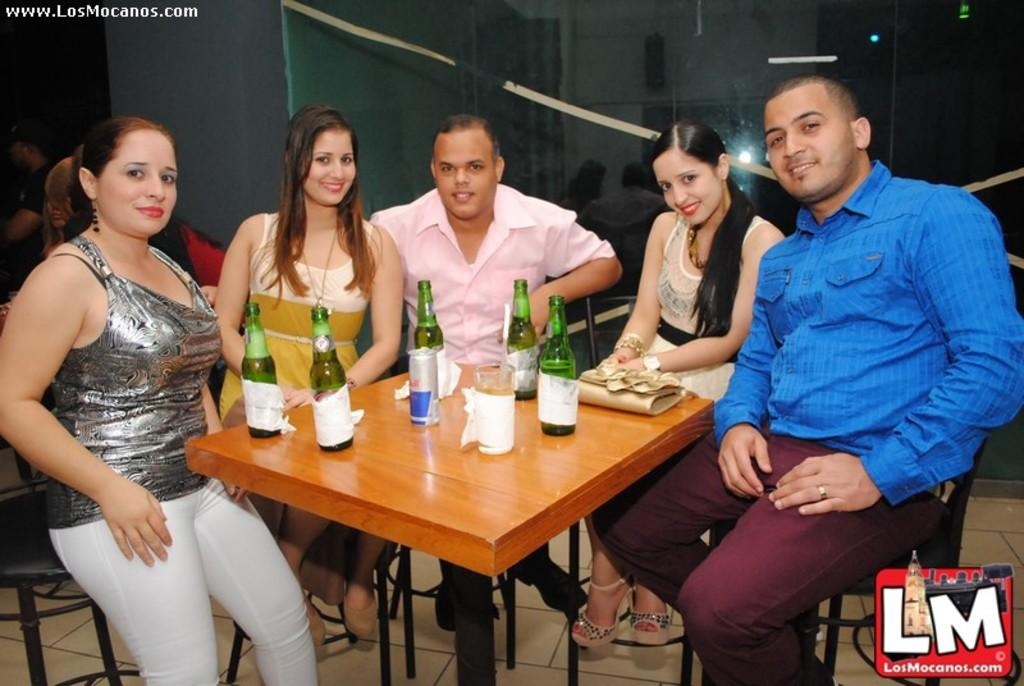What are the people in the image doing? The people in the image are sitting on chairs. What is in front of the chairs? There is a table in front of the chairs. What items can be seen on the table? There are bottles and glasses on the table. What kind of development is taking place in the image? There is no indication of any development taking place in the image; it simply shows people sitting on chairs with a table and bottles and glasses in front of them. 